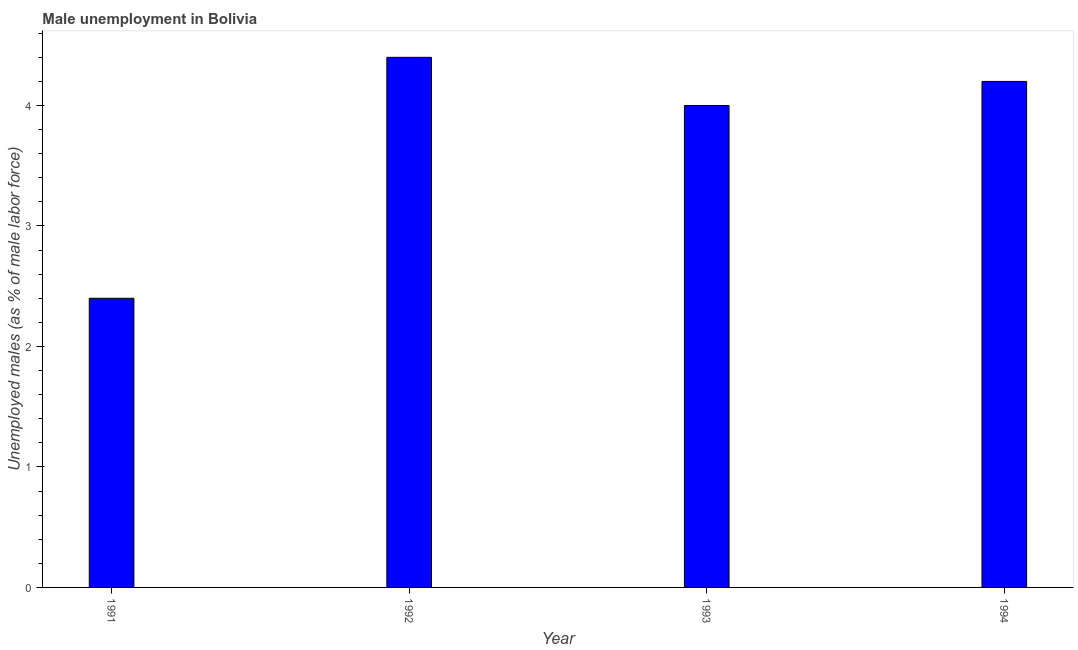Does the graph contain any zero values?
Provide a short and direct response. No. What is the title of the graph?
Offer a very short reply. Male unemployment in Bolivia. What is the label or title of the Y-axis?
Give a very brief answer. Unemployed males (as % of male labor force). What is the unemployed males population in 1991?
Keep it short and to the point. 2.4. Across all years, what is the maximum unemployed males population?
Provide a short and direct response. 4.4. Across all years, what is the minimum unemployed males population?
Your answer should be very brief. 2.4. In which year was the unemployed males population maximum?
Your response must be concise. 1992. In which year was the unemployed males population minimum?
Provide a succinct answer. 1991. What is the difference between the unemployed males population in 1992 and 1993?
Provide a succinct answer. 0.4. What is the average unemployed males population per year?
Your answer should be very brief. 3.75. What is the median unemployed males population?
Provide a short and direct response. 4.1. In how many years, is the unemployed males population greater than 2.6 %?
Offer a terse response. 3. What is the ratio of the unemployed males population in 1993 to that in 1994?
Your answer should be compact. 0.95. What is the difference between the highest and the second highest unemployed males population?
Give a very brief answer. 0.2. Is the sum of the unemployed males population in 1991 and 1993 greater than the maximum unemployed males population across all years?
Your answer should be compact. Yes. In how many years, is the unemployed males population greater than the average unemployed males population taken over all years?
Your answer should be compact. 3. How many bars are there?
Offer a terse response. 4. How many years are there in the graph?
Provide a succinct answer. 4. What is the difference between two consecutive major ticks on the Y-axis?
Your answer should be very brief. 1. What is the Unemployed males (as % of male labor force) of 1991?
Your answer should be very brief. 2.4. What is the Unemployed males (as % of male labor force) in 1992?
Give a very brief answer. 4.4. What is the Unemployed males (as % of male labor force) in 1993?
Give a very brief answer. 4. What is the Unemployed males (as % of male labor force) of 1994?
Offer a very short reply. 4.2. What is the difference between the Unemployed males (as % of male labor force) in 1991 and 1993?
Provide a succinct answer. -1.6. What is the difference between the Unemployed males (as % of male labor force) in 1991 and 1994?
Keep it short and to the point. -1.8. What is the difference between the Unemployed males (as % of male labor force) in 1992 and 1993?
Give a very brief answer. 0.4. What is the difference between the Unemployed males (as % of male labor force) in 1992 and 1994?
Give a very brief answer. 0.2. What is the difference between the Unemployed males (as % of male labor force) in 1993 and 1994?
Provide a short and direct response. -0.2. What is the ratio of the Unemployed males (as % of male labor force) in 1991 to that in 1992?
Keep it short and to the point. 0.55. What is the ratio of the Unemployed males (as % of male labor force) in 1991 to that in 1993?
Keep it short and to the point. 0.6. What is the ratio of the Unemployed males (as % of male labor force) in 1991 to that in 1994?
Provide a succinct answer. 0.57. What is the ratio of the Unemployed males (as % of male labor force) in 1992 to that in 1994?
Offer a very short reply. 1.05. 